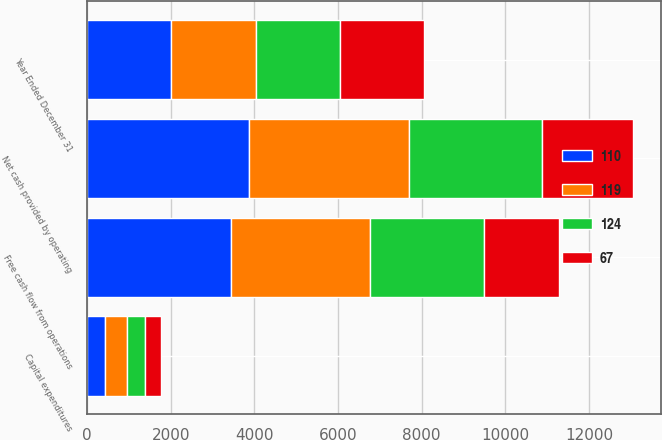<chart> <loc_0><loc_0><loc_500><loc_500><stacked_bar_chart><ecel><fcel>Year Ended December 31<fcel>Net cash provided by operating<fcel>Capital expenditures<fcel>Free cash flow from operations<nl><fcel>110<fcel>2017<fcel>3879<fcel>428<fcel>3451<nl><fcel>67<fcel>2016<fcel>2198<fcel>392<fcel>1806<nl><fcel>119<fcel>2014<fcel>3828<fcel>521<fcel>3307<nl><fcel>124<fcel>2013<fcel>3159<fcel>436<fcel>2723<nl></chart> 